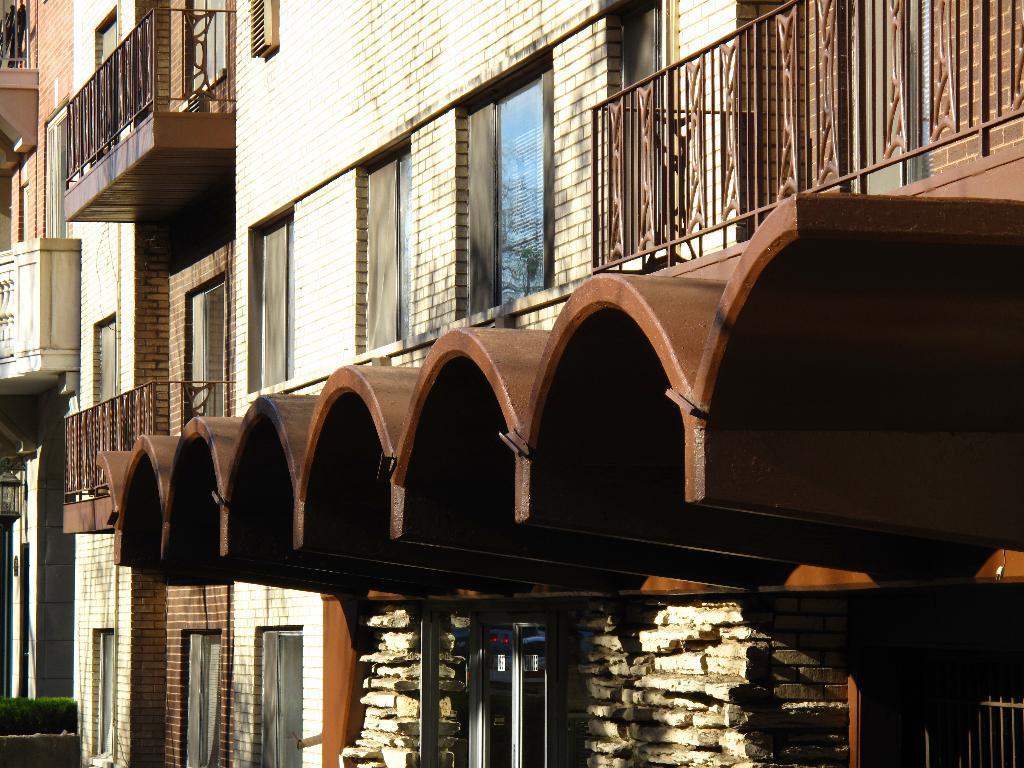Describe this image in one or two sentences. In the picture I can see a building with glass windows, steel railing and shelter. 